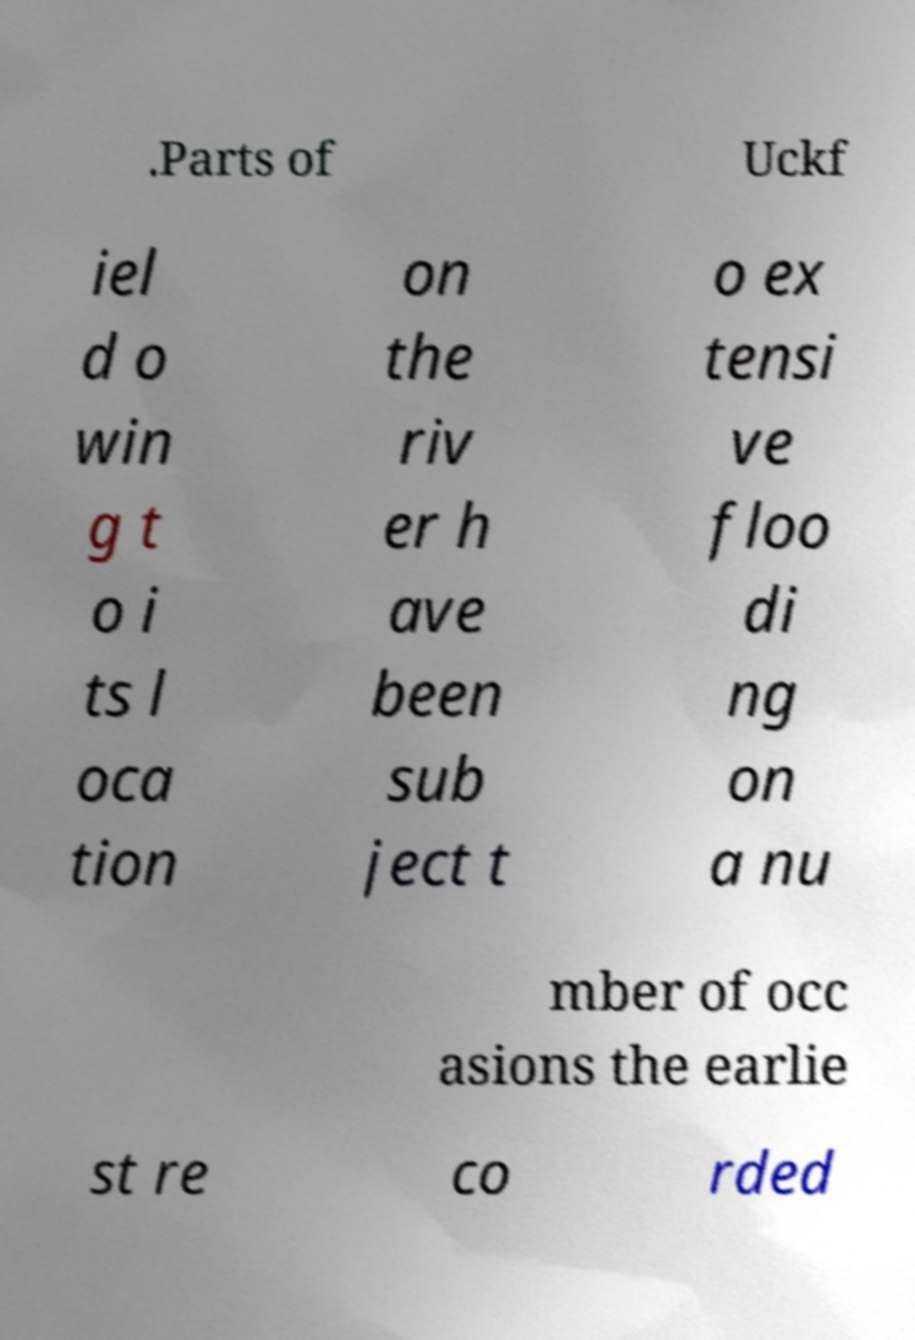Could you assist in decoding the text presented in this image and type it out clearly? .Parts of Uckf iel d o win g t o i ts l oca tion on the riv er h ave been sub ject t o ex tensi ve floo di ng on a nu mber of occ asions the earlie st re co rded 